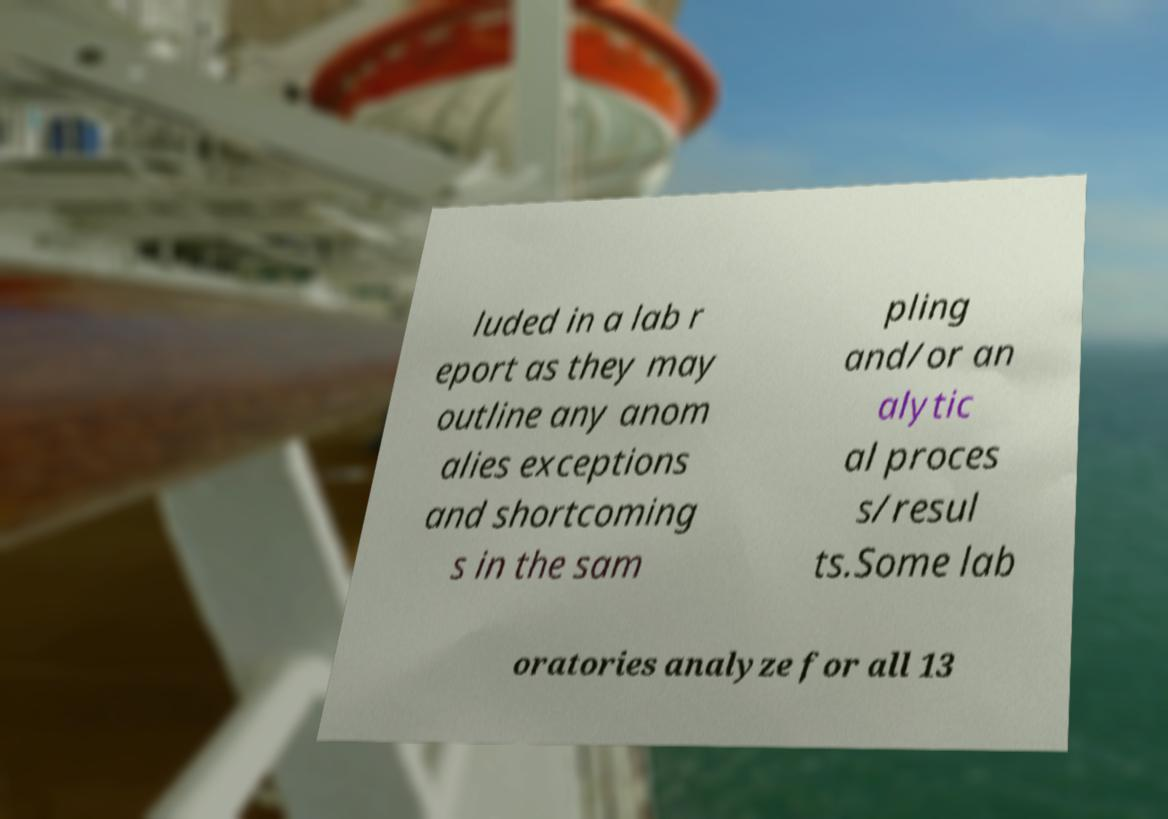For documentation purposes, I need the text within this image transcribed. Could you provide that? luded in a lab r eport as they may outline any anom alies exceptions and shortcoming s in the sam pling and/or an alytic al proces s/resul ts.Some lab oratories analyze for all 13 